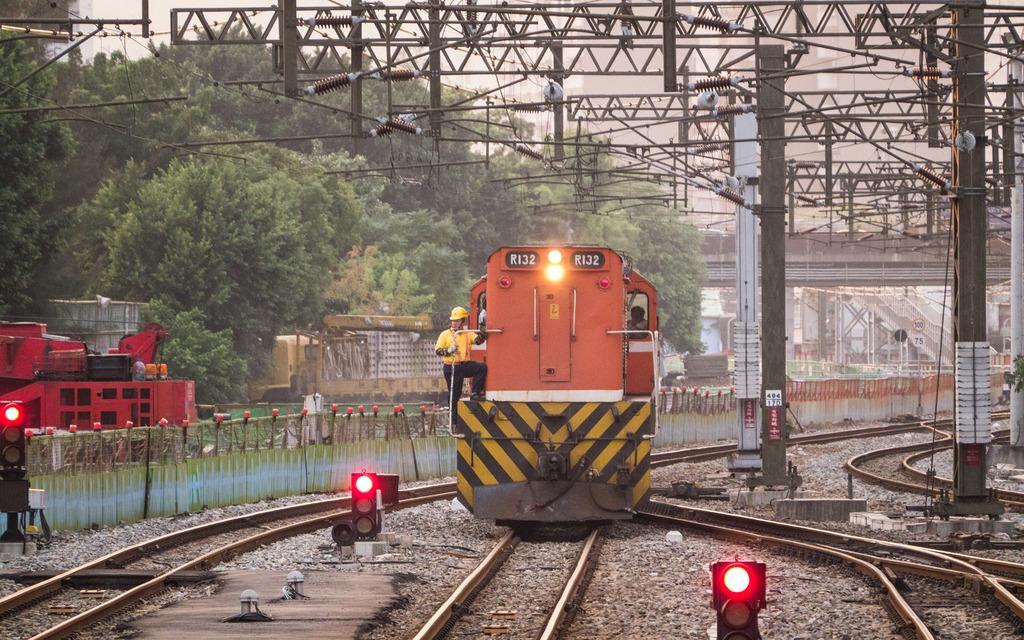Could you give a brief overview of what you see in this image? In this picture there is a train in the center of the image and there is another train on the left side of the image, there are tracks and traffic lights at the bottom side of the image and there is a boundary behind the train, there are poles in the image and there are houses and trees in the background area of the image. 